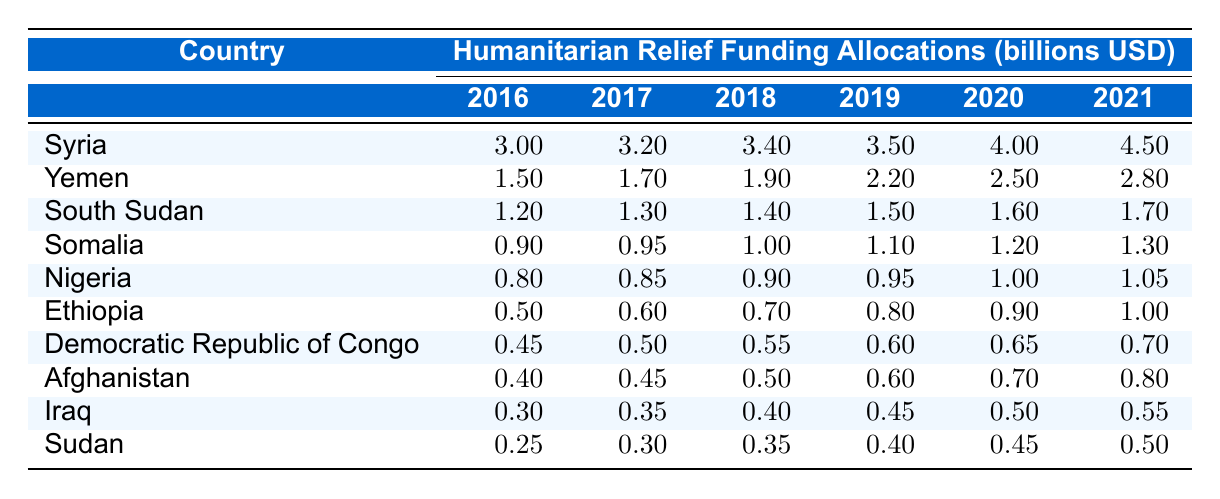What was the funding allocation for Yemen in 2020? The table shows the funding allocation for Yemen in 2020 to be 2.50 billion USD.
Answer: 2.50 billion USD Which country received the highest humanitarian relief funding in 2021? According to the table, Syria received the highest funding allocation in 2021 with 4.50 billion USD.
Answer: Syria What is the average funding allocation for South Sudan from 2016 to 2021? The funding allocations for South Sudan are: 1.20, 1.30, 1.40, 1.50, 1.60, and 1.70 billion USD. The total sum is 1.20 + 1.30 + 1.40 + 1.50 + 1.60 + 1.70 = 7.70 billion USD. The average is 7.70 / 6 = 1.2833 billion USD.
Answer: 1.28 billion USD Did Yemen's funding allocation increase every year from 2016 to 2021? By reviewing the funding allocations for Yemen, they were 1.50, 1.70, 1.90, 2.20, 2.50, and 2.80 billion USD, showing a consistent increase each year.
Answer: Yes Which two countries had the same funding allocation in 2018? The table shows that both Ethiopia and South Sudan had funding allocations of 1.40 billion USD in 2018.
Answer: Ethiopia and South Sudan What was the total funding for Somalia between 2016 and 2021? The funding for Somalia from 2016 to 2021 is as follows: 0.90 + 0.95 + 1.00 + 1.10 + 1.20 + 1.30 = 5.45 billion USD.
Answer: 5.45 billion USD What is the difference in funding allocation between Somalia in 2016 and Nigeria in 2021? Somalia received 0.90 billion USD in 2016, and Nigeria received 1.05 billion USD in 2021. The difference is 1.05 - 0.90 = 0.15 billion USD.
Answer: 0.15 billion USD In which year did the Democratic Republic of Congo experience the largest increase in funding allocation? The funding allocations for the Democratic Republic of Congo are 0.45, 0.50, 0.55, 0.60, 0.65, and 0.70 billion USD from 2016 to 2021. The largest increase is from 0.60 to 0.65 billion USD, which is 0.05 billion USD from 2020 to 2021.
Answer: 2020 to 2021 